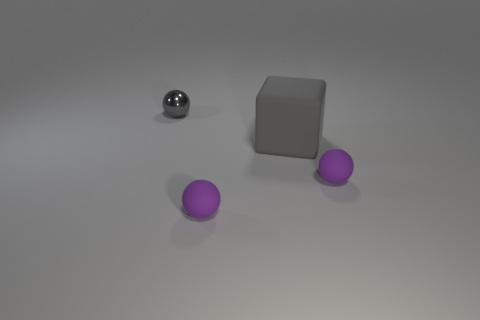What shape is the shiny thing that is the same color as the big cube?
Offer a very short reply. Sphere. Does the gray thing that is to the right of the gray shiny object have the same size as the shiny object?
Offer a very short reply. No. Are there any large matte balls of the same color as the small metal object?
Keep it short and to the point. No. Is the number of rubber cubes right of the big gray block greater than the number of gray rubber blocks that are behind the metal sphere?
Give a very brief answer. No. What number of other things are made of the same material as the tiny gray ball?
Your response must be concise. 0. Does the gray object that is in front of the small gray object have the same material as the tiny gray object?
Your answer should be compact. No. The gray metal object has what shape?
Provide a short and direct response. Sphere. Are there more tiny balls that are in front of the tiny gray sphere than tiny spheres?
Provide a succinct answer. No. Is there any other thing that has the same shape as the gray rubber object?
Offer a very short reply. No. There is a tiny metallic thing behind the block; what is its shape?
Make the answer very short. Sphere. 